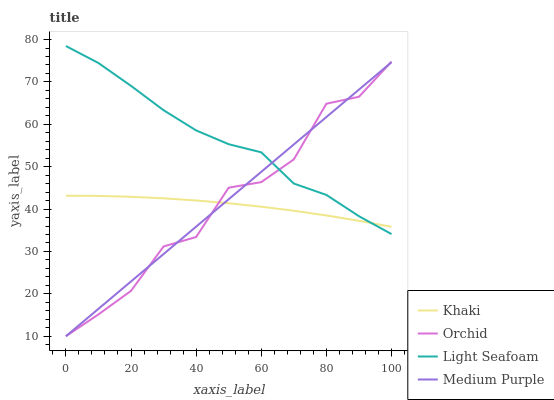Does Light Seafoam have the minimum area under the curve?
Answer yes or no. No. Does Khaki have the maximum area under the curve?
Answer yes or no. No. Is Khaki the smoothest?
Answer yes or no. No. Is Khaki the roughest?
Answer yes or no. No. Does Light Seafoam have the lowest value?
Answer yes or no. No. Does Khaki have the highest value?
Answer yes or no. No. 